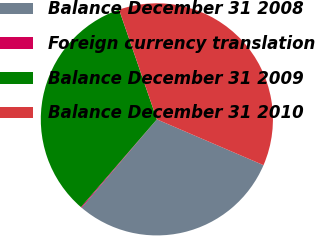<chart> <loc_0><loc_0><loc_500><loc_500><pie_chart><fcel>Balance December 31 2008<fcel>Foreign currency translation<fcel>Balance December 31 2009<fcel>Balance December 31 2010<nl><fcel>29.76%<fcel>0.13%<fcel>33.37%<fcel>36.74%<nl></chart> 